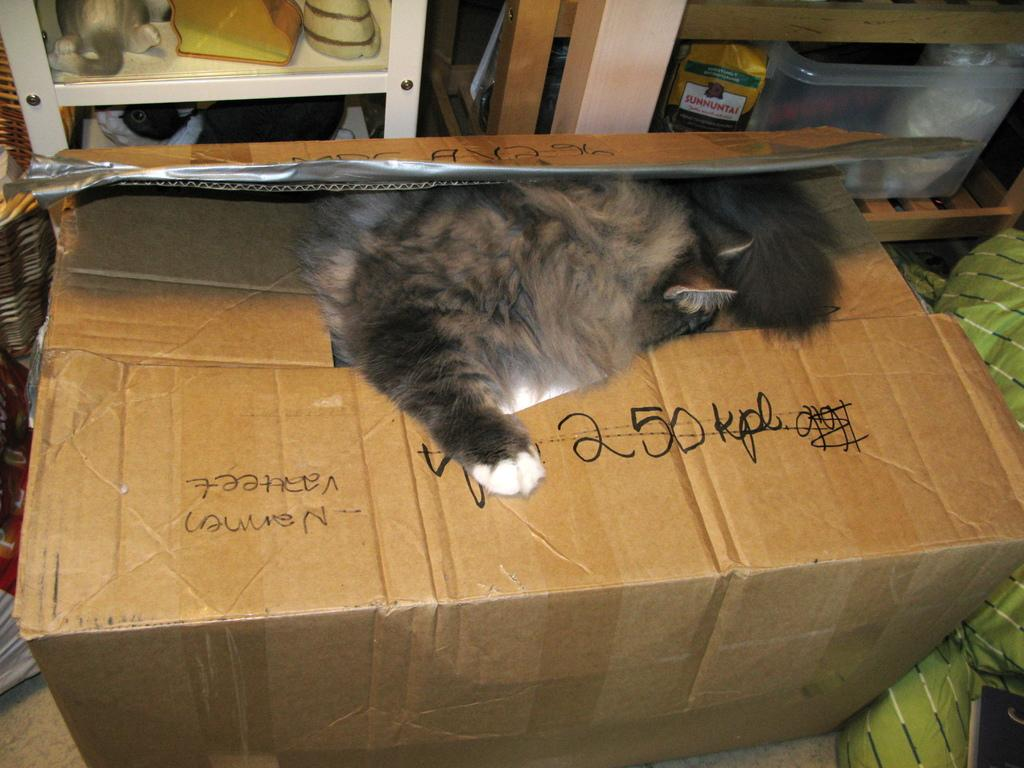<image>
Render a clear and concise summary of the photo. A cat sits on top of a box that has 250 kpl written on it in black marker. 